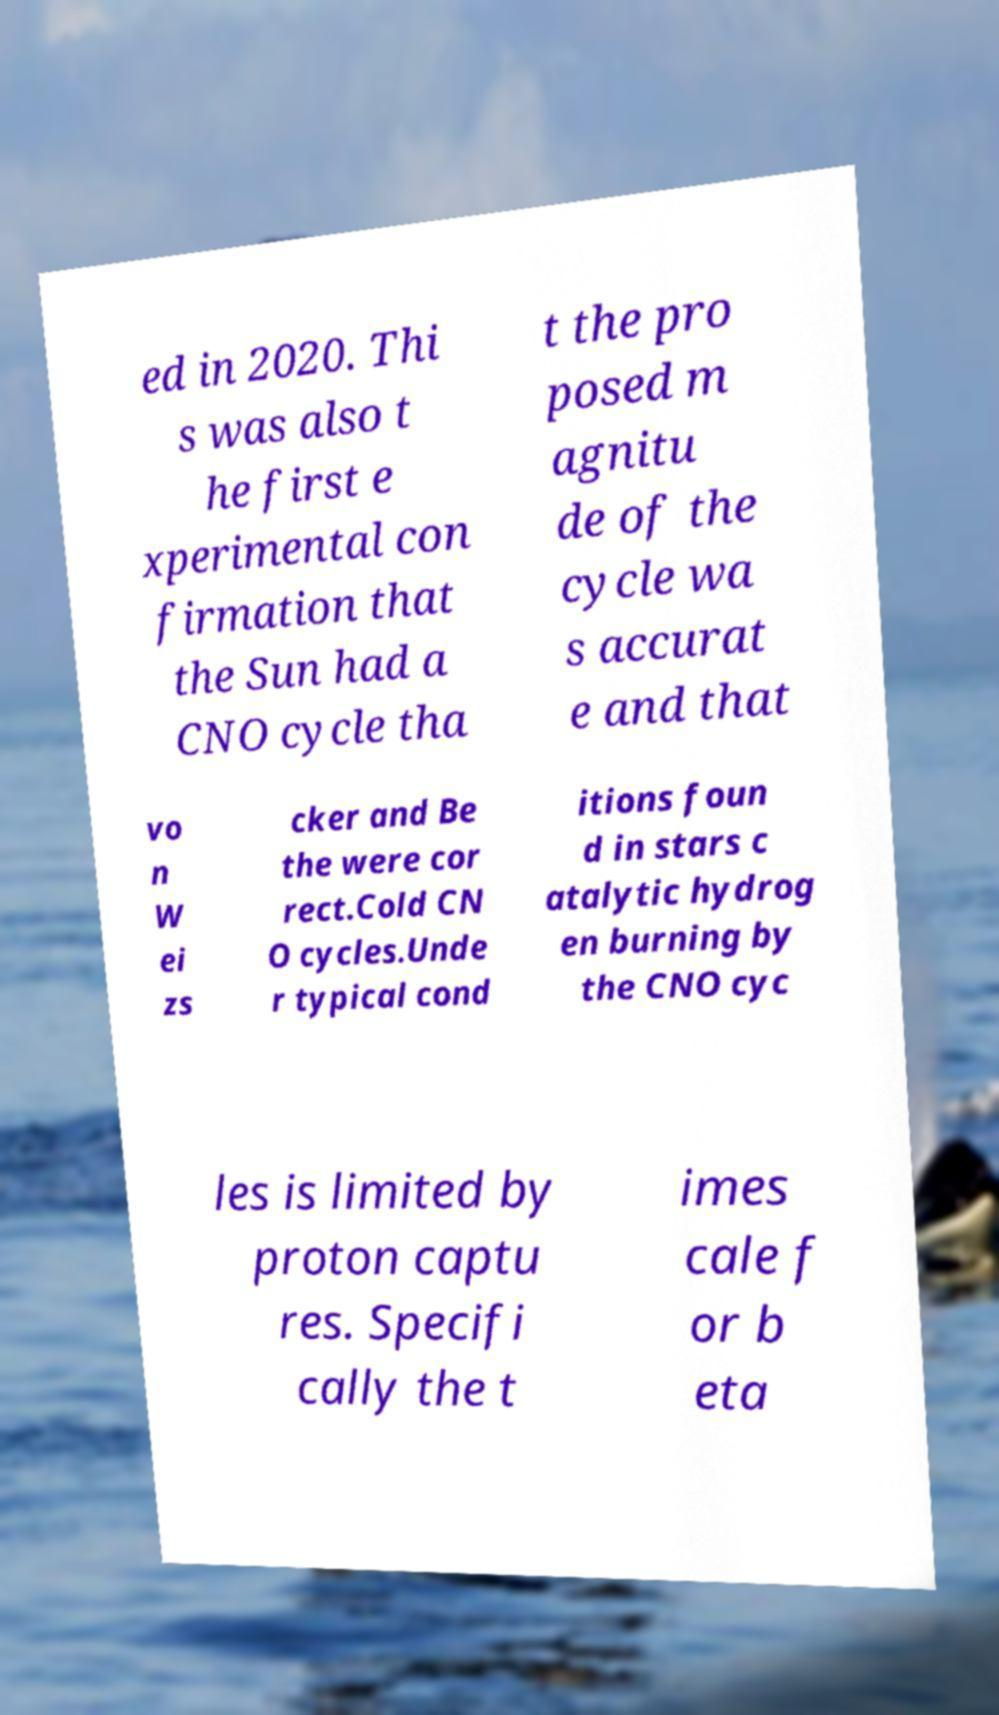What messages or text are displayed in this image? I need them in a readable, typed format. ed in 2020. Thi s was also t he first e xperimental con firmation that the Sun had a CNO cycle tha t the pro posed m agnitu de of the cycle wa s accurat e and that vo n W ei zs cker and Be the were cor rect.Cold CN O cycles.Unde r typical cond itions foun d in stars c atalytic hydrog en burning by the CNO cyc les is limited by proton captu res. Specifi cally the t imes cale f or b eta 